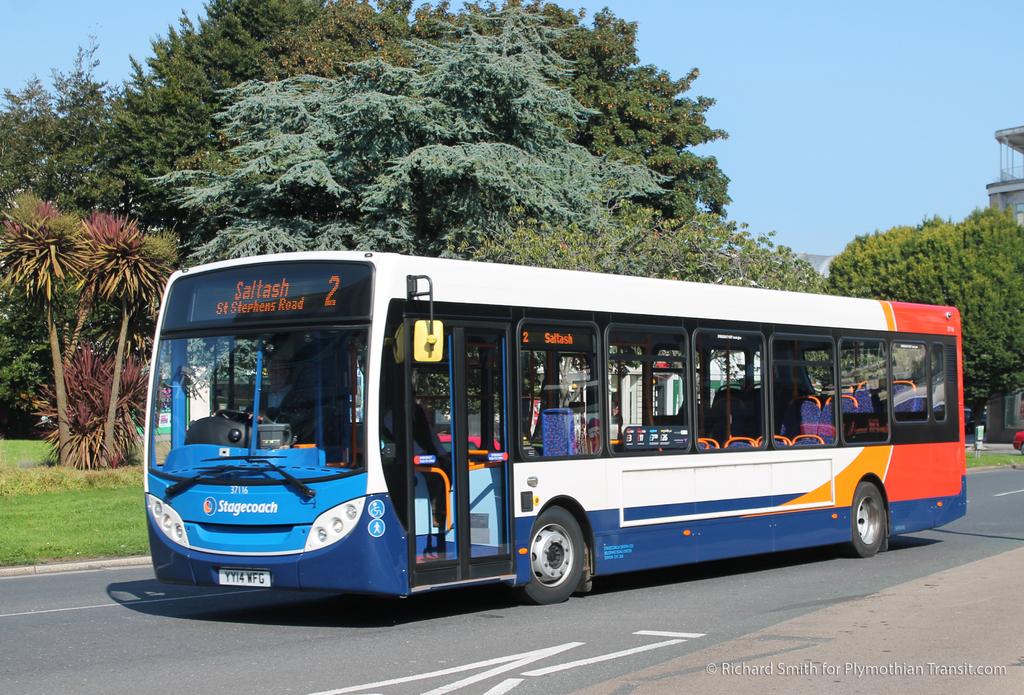What is the bus number?
Offer a very short reply. 2. What road is the bus headed to?
Offer a terse response. St stephens. 